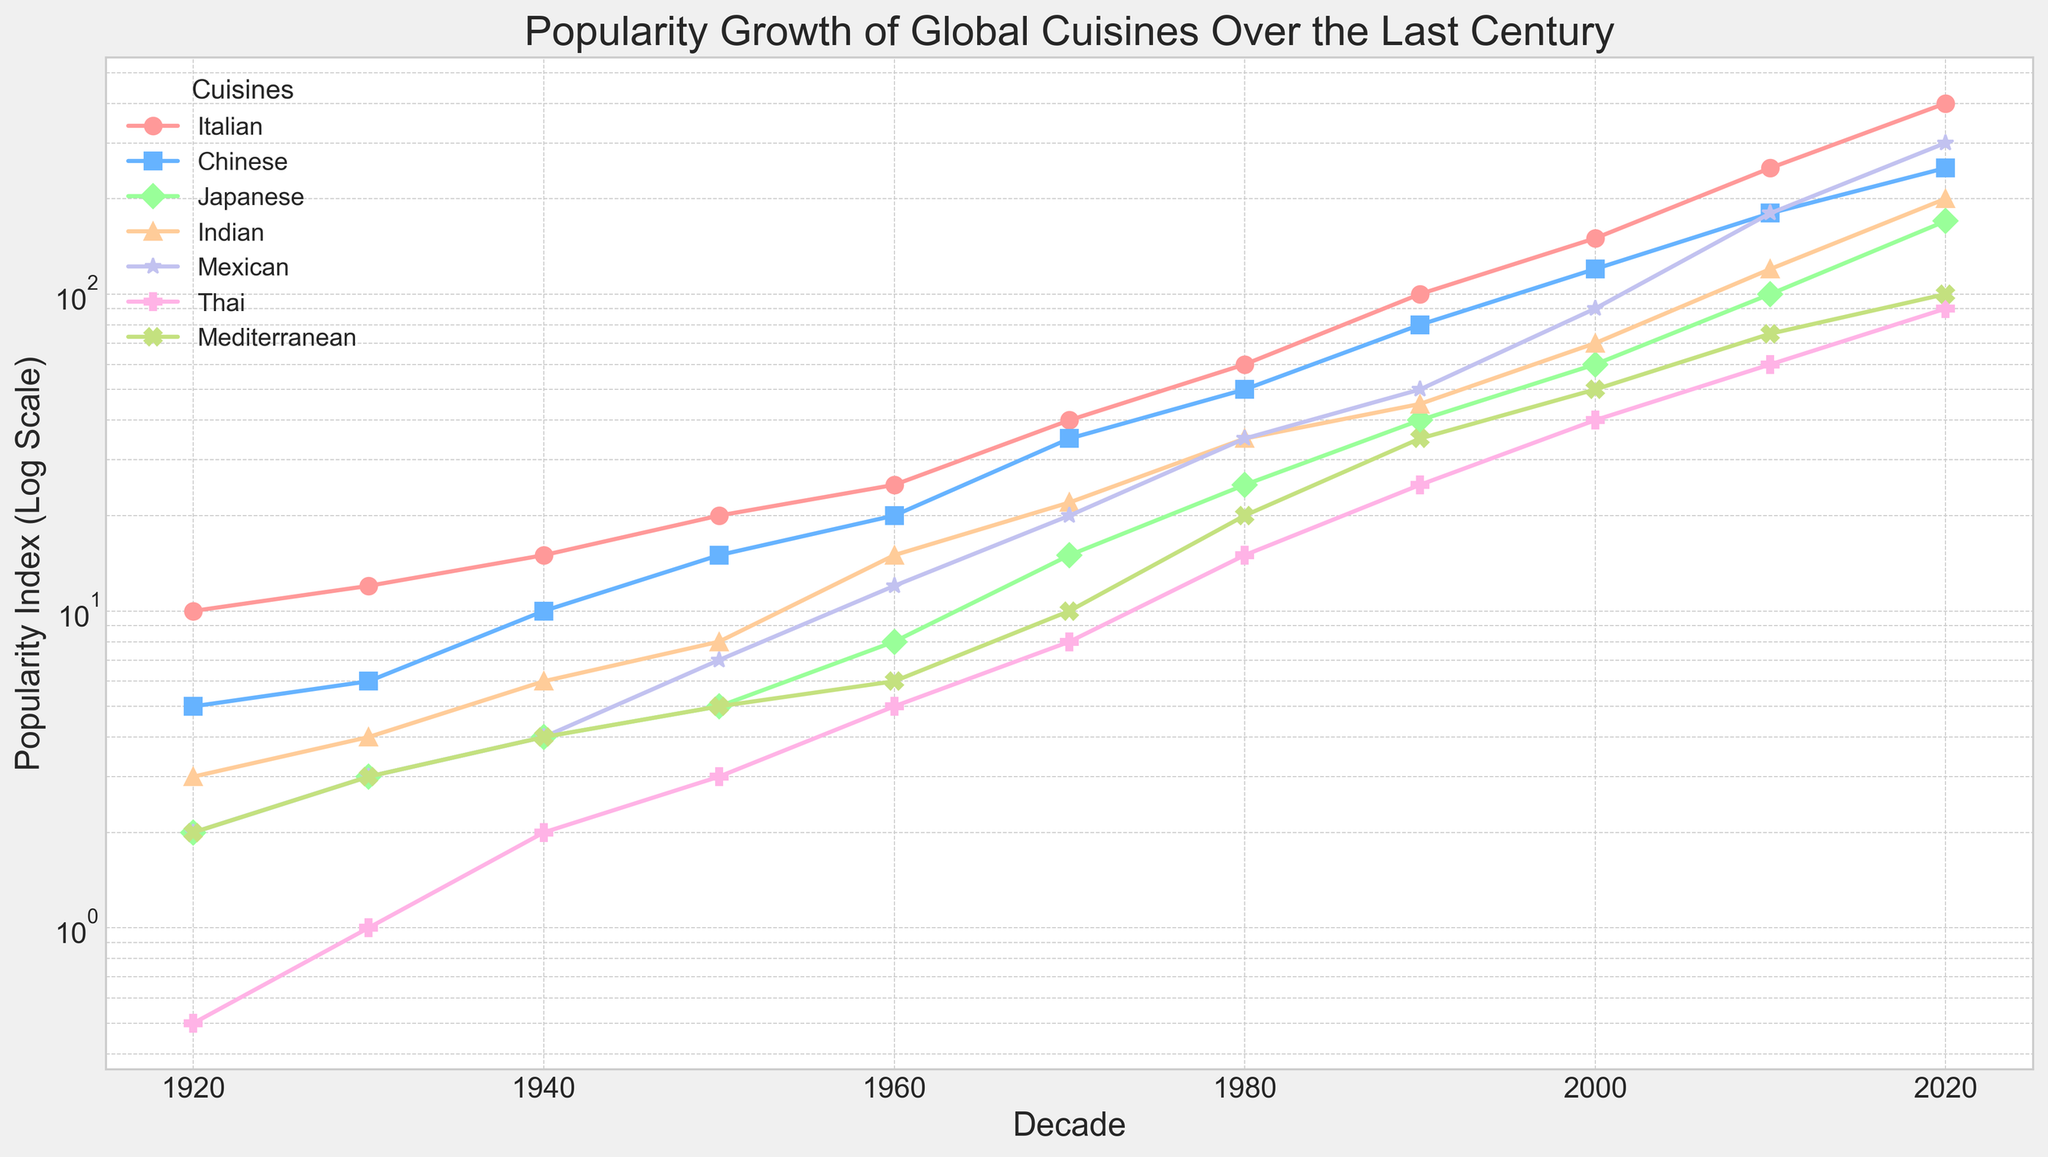what is the overall trend for the Italian cuisine popularity over the last century? The popularity of Italian cuisine generally increases over the decades, starting from 10 in the 1920s and reaching 400 in the 2020s.
Answer: Increasing What year did Mexican cuisine surpass Italian cuisine in popularity? Mexican cuisine never surpasses Italian cuisine in popularity at any point in this figure. Italian cuisine consistently has higher popularity values compared to Mexican cuisine throughout the century.
Answer: Never Which cuisine experienced the highest growth rate between 2000 and 2010? By comparing the values, the highest growth rate is observed in Indian cuisine, which increased from 70 in 2000 to 120 in 2010. The growth rate (120-70)/70 = 0.714 or 71.4%.
Answer: Indian In the 1970s, how many times more popular was Italian cuisine compared to Mediterranean cuisine? The popularity of Italian cuisine in the 1970s was 40, while Mediterranean was 10. Ratio: 40/10 = 4.
Answer: 4 times Between which decades did Japanese cuisine see its most substantial growth? Comparing the growth of Japanese cuisine between each decade: the most significant increase is between the 2000s (60) and 2010s (100). Growth rate: (100-60)/60 = 0.666 or 66.6%.
Answer: 2000 to 2010 Which cuisine had the smallest growth rate between 1980 and 1990? The smallest growth rate is in Chinese cuisine, which increased from 50 in 1980 to 80 in 1990. Growth rate: (80-50)/50 = 0.6 or 60%.
Answer: Chinese Which cuisine is represented by the color blue on the plot? The color blue represents Chinese cuisine.
Answer: Chinese In which decade did Thai cuisine first surpass Mediterranean cuisine in popularity? By looking at the values, Thai cuisine first surpasses Mediterranean cuisine in the 2010s, with Thai at 60 and Mediterranean at 50.
Answer: 2010 